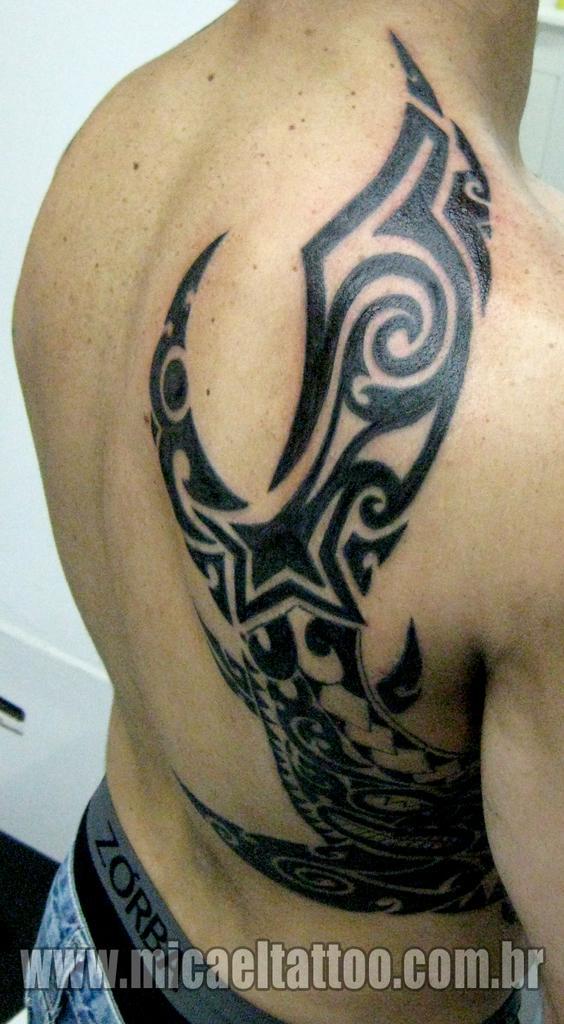Please provide a concise description of this image. In this image there is a tattoo on the body of the person, there is some text written at the bottom of the image. 